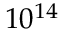Convert formula to latex. <formula><loc_0><loc_0><loc_500><loc_500>1 0 ^ { 1 4 }</formula> 